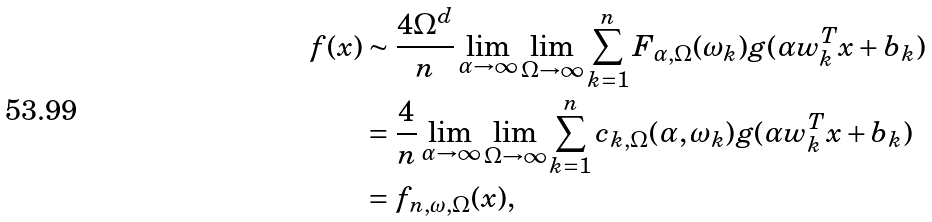Convert formula to latex. <formula><loc_0><loc_0><loc_500><loc_500>f ( x ) & \sim \frac { 4 \Omega ^ { d } } { n } \lim _ { \alpha \rightarrow \infty } \lim _ { \Omega \rightarrow \infty } \sum _ { k = 1 } ^ { n } F _ { \alpha , \Omega } ( \omega _ { k } ) g ( \alpha w ^ { T } _ { k } x + b _ { k } ) \\ & = \frac { 4 } { n } \lim _ { \alpha \rightarrow \infty } \lim _ { \Omega \rightarrow \infty } \sum _ { k = 1 } ^ { n } c _ { k , \Omega } ( \alpha , \omega _ { k } ) g ( \alpha w ^ { T } _ { k } x + b _ { k } ) \\ & = f _ { n , \omega , \Omega } ( x ) ,</formula> 